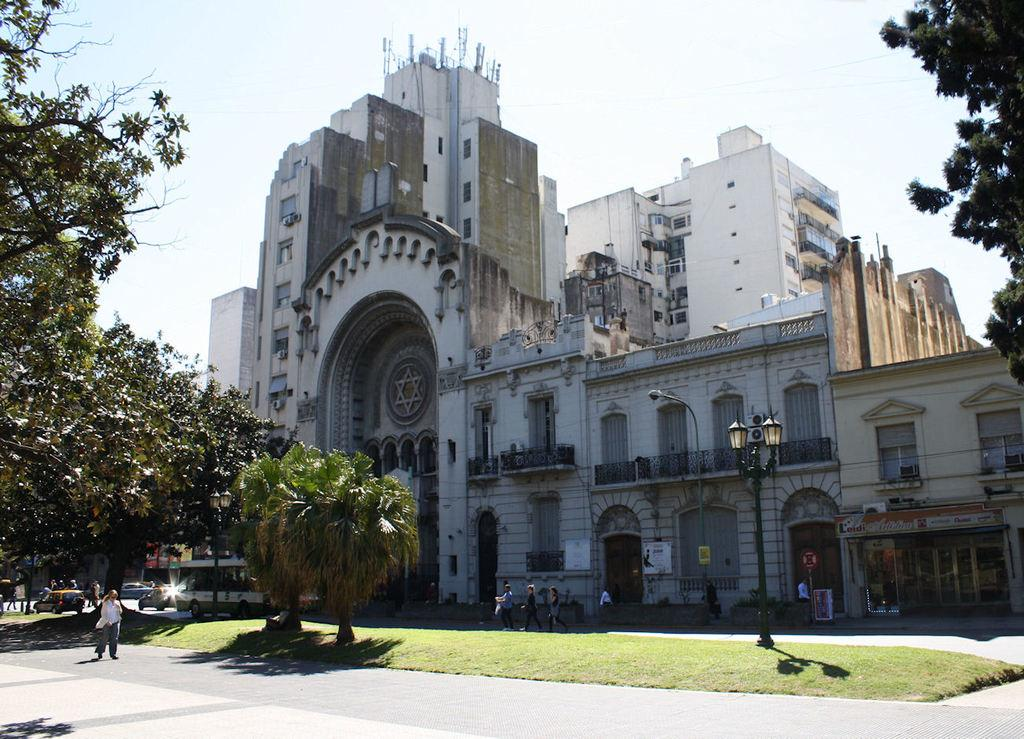What type of structures can be seen in the image? There are buildings in the image. What natural elements are present in the image? There are trees in the image. What are the vertical objects in the image? There are poles in the image. What are the illumination sources in the image? There are lights in the image. What flat, rectangular objects can be seen in the image? There are boards in the image. What mode of transportation is visible in the image? There are vehicles in the image. Who or what is present in the image? There are people in the image. What type of pathway is included in the image? The image includes a road. What type of arch can be seen in the image? There is no arch present in the image. What stage of development is the area in the image? The image does not provide information about the development stage of the area. 